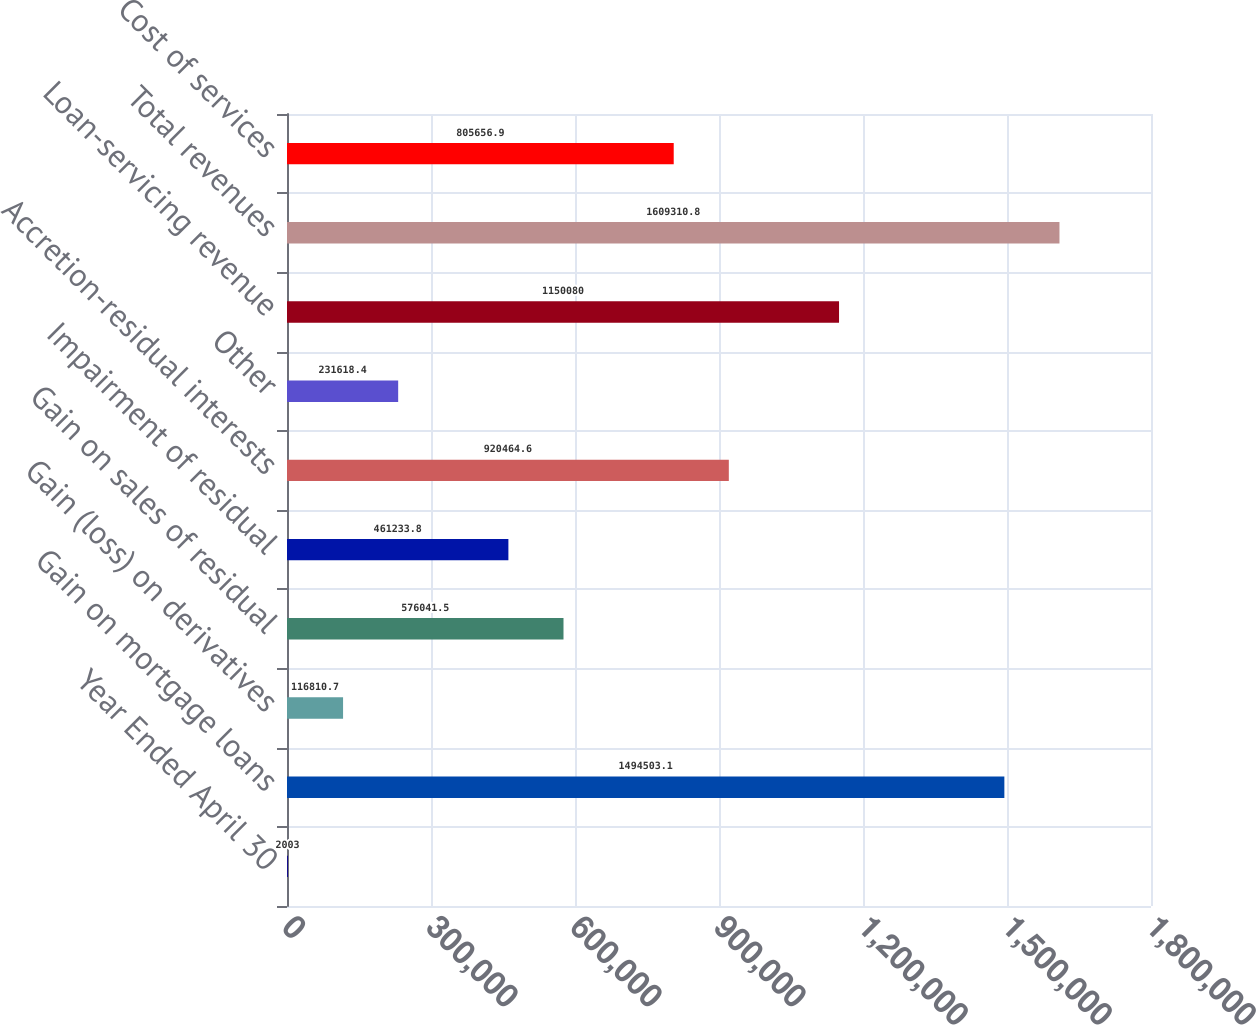Convert chart to OTSL. <chart><loc_0><loc_0><loc_500><loc_500><bar_chart><fcel>Year Ended April 30<fcel>Gain on mortgage loans<fcel>Gain (loss) on derivatives<fcel>Gain on sales of residual<fcel>Impairment of residual<fcel>Accretion-residual interests<fcel>Other<fcel>Loan-servicing revenue<fcel>Total revenues<fcel>Cost of services<nl><fcel>2003<fcel>1.4945e+06<fcel>116811<fcel>576042<fcel>461234<fcel>920465<fcel>231618<fcel>1.15008e+06<fcel>1.60931e+06<fcel>805657<nl></chart> 